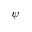Convert formula to latex. <formula><loc_0><loc_0><loc_500><loc_500>\psi</formula> 